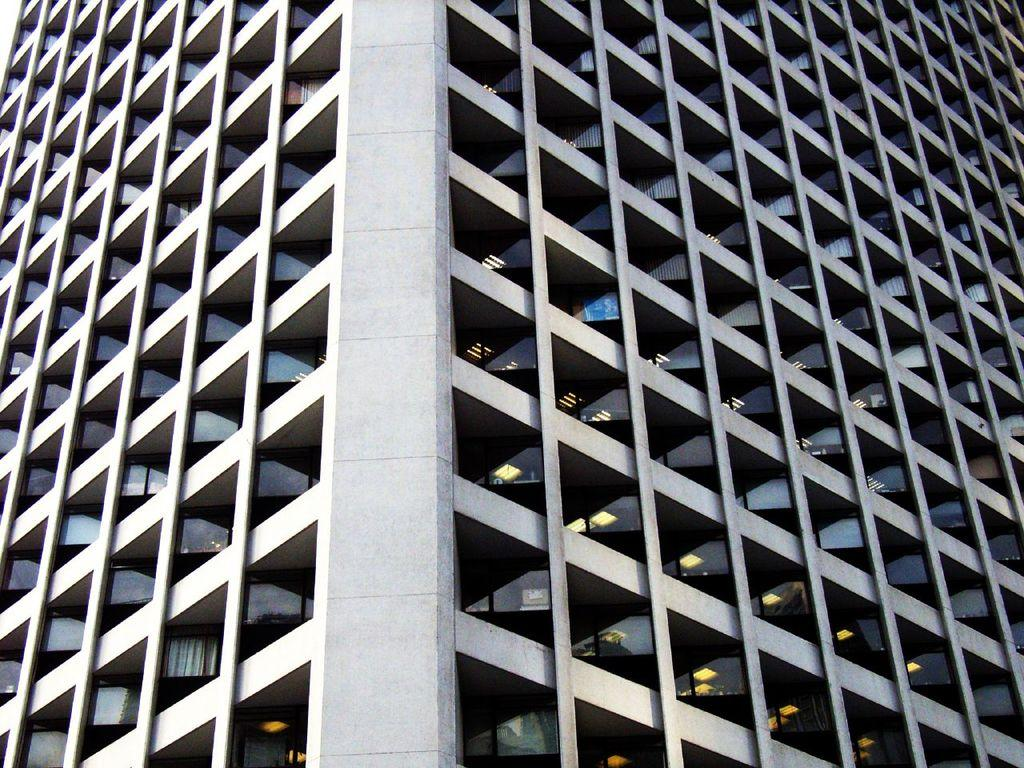What is the main structure visible in the image? There is a building in the image. What can be seen inside the building? Lights are visible in the building. Are there any other objects or features present in the building? Yes, there are other objects present in the building. Can you tell me what type of surprise is hidden in the building? There is no mention of a surprise in the image, so it cannot be determined what type of surprise might be hidden. 